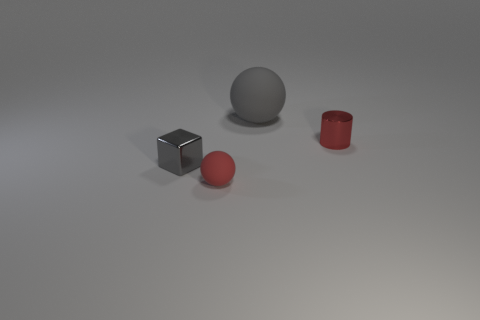There is a thing that is to the right of the red rubber object and in front of the big gray thing; what is it made of?
Ensure brevity in your answer.  Metal. Is the red shiny cylinder the same size as the cube?
Offer a very short reply. Yes. What is the size of the thing that is in front of the metal object to the left of the gray rubber ball?
Offer a very short reply. Small. What number of things are both right of the cube and left of the big gray object?
Your response must be concise. 1. There is a tiny shiny thing that is right of the tiny shiny thing left of the tiny cylinder; are there any tiny shiny cylinders in front of it?
Ensure brevity in your answer.  No. There is a red rubber thing that is the same size as the gray metallic thing; what shape is it?
Offer a terse response. Sphere. Are there any large objects that have the same color as the block?
Provide a short and direct response. Yes. Is the small red metal thing the same shape as the large rubber object?
Offer a terse response. No. What number of big things are red rubber balls or red rubber cylinders?
Offer a very short reply. 0. There is a big object that is the same material as the small sphere; what color is it?
Your answer should be compact. Gray. 